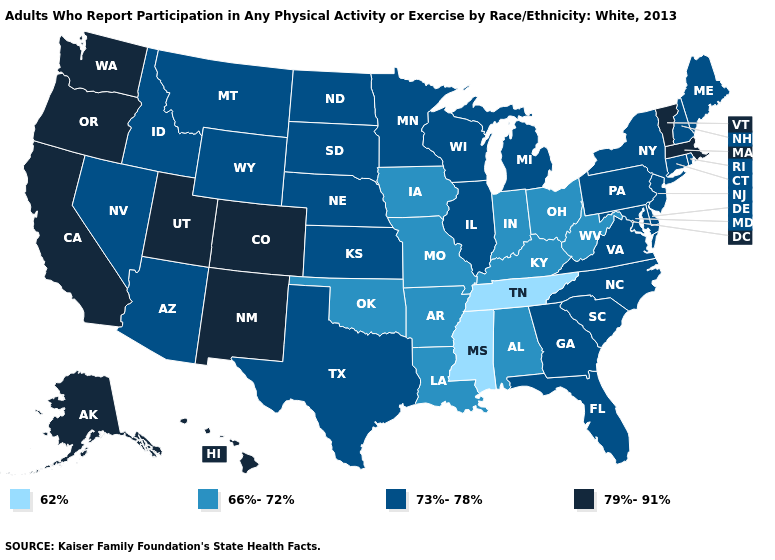Among the states that border Nevada , does Idaho have the highest value?
Quick response, please. No. What is the value of Alabama?
Answer briefly. 66%-72%. Does the first symbol in the legend represent the smallest category?
Quick response, please. Yes. Does Washington have a lower value than Maine?
Quick response, please. No. Does Colorado have the highest value in the West?
Short answer required. Yes. Name the states that have a value in the range 66%-72%?
Concise answer only. Alabama, Arkansas, Indiana, Iowa, Kentucky, Louisiana, Missouri, Ohio, Oklahoma, West Virginia. Among the states that border Missouri , which have the lowest value?
Keep it brief. Tennessee. Name the states that have a value in the range 66%-72%?
Concise answer only. Alabama, Arkansas, Indiana, Iowa, Kentucky, Louisiana, Missouri, Ohio, Oklahoma, West Virginia. What is the highest value in the South ?
Write a very short answer. 73%-78%. Among the states that border Arkansas , does Oklahoma have the lowest value?
Quick response, please. No. Name the states that have a value in the range 62%?
Concise answer only. Mississippi, Tennessee. Name the states that have a value in the range 73%-78%?
Short answer required. Arizona, Connecticut, Delaware, Florida, Georgia, Idaho, Illinois, Kansas, Maine, Maryland, Michigan, Minnesota, Montana, Nebraska, Nevada, New Hampshire, New Jersey, New York, North Carolina, North Dakota, Pennsylvania, Rhode Island, South Carolina, South Dakota, Texas, Virginia, Wisconsin, Wyoming. Among the states that border New York , does New Jersey have the lowest value?
Concise answer only. Yes. What is the value of Wisconsin?
Quick response, please. 73%-78%. What is the lowest value in the USA?
Answer briefly. 62%. 